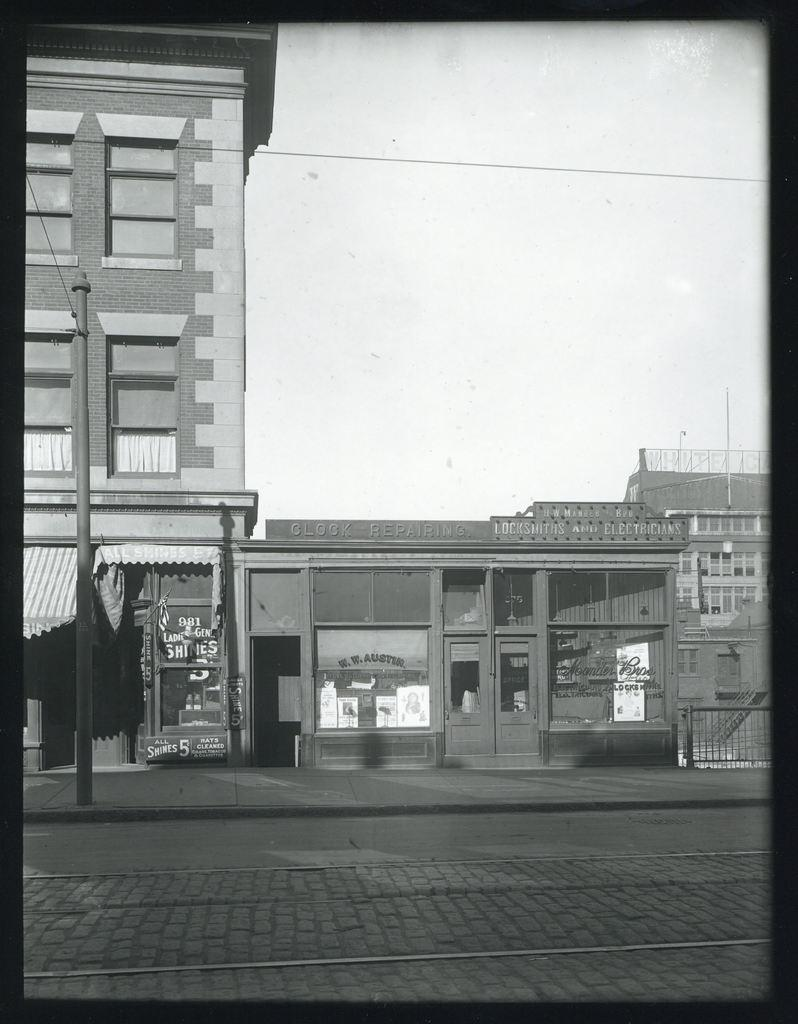What is the color scheme of the image? The image is black and white. What can be seen in the background of the image? There are buildings in the background of the image. What is located in front of the buildings? There is a road in front of the buildings. What part of the natural environment is visible in the image? The sky is visible in the image. What type of stew is being cooked on the road in the image? There is no stew or cooking activity present in the image; it features a road in front of buildings with a visible sky. 